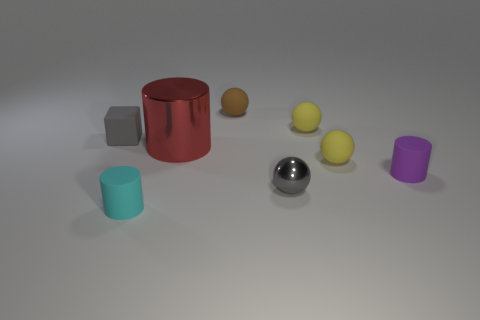How many yellow spheres must be subtracted to get 1 yellow spheres? 1 Add 1 tiny gray objects. How many objects exist? 9 Subtract all large red metallic cylinders. How many cylinders are left? 2 Subtract all cylinders. How many objects are left? 5 Subtract 0 brown cubes. How many objects are left? 8 Subtract 2 cylinders. How many cylinders are left? 1 Subtract all cyan spheres. Subtract all gray blocks. How many spheres are left? 4 Subtract all yellow spheres. How many purple cylinders are left? 1 Subtract all tiny green cylinders. Subtract all cyan cylinders. How many objects are left? 7 Add 2 big red things. How many big red things are left? 3 